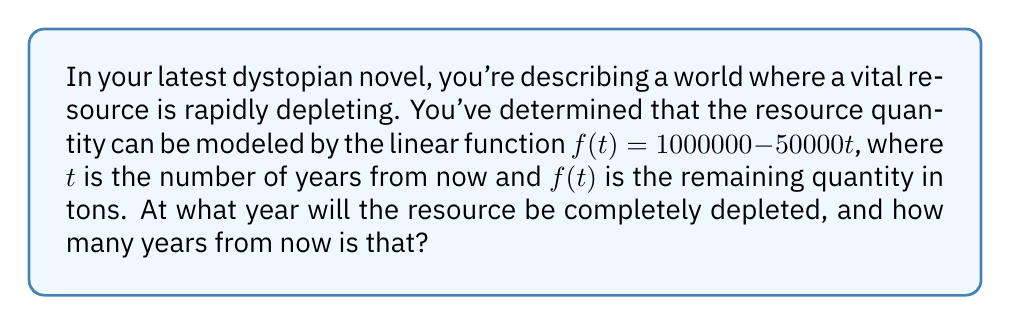Solve this math problem. To solve this problem, we need to follow these steps:

1) The resource will be depleted when $f(t) = 0$. So, we need to solve the equation:

   $1000000 - 50000t = 0$

2) Add 50000t to both sides:

   $1000000 = 50000t$

3) Divide both sides by 50000:

   $\frac{1000000}{50000} = t$

4) Simplify:

   $20 = t$

5) This means the resource will be depleted in 20 years from now.

6) To determine the actual year, we need to add 20 to the current year. Let's assume the current year is 2023:

   $2023 + 20 = 2043$

Therefore, the resource will be completely depleted in the year 2043, which is 20 years from now.
Answer: 2043; 20 years 